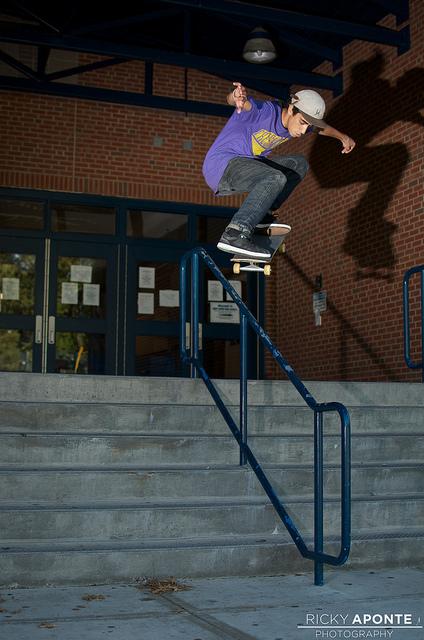What is the skateboard up against?
Answer briefly. Railing. What is behind this person?
Answer briefly. Building. Who is on the man's shirt?
Keep it brief. Warriors. What does the boy's shirt say?
Short answer required. Nothing. What is in the picture?
Answer briefly. Skateboarder. How many steps of stairs are there?
Answer briefly. 6. Is this a British motorbike?
Concise answer only. No. Is there writing on the rail?
Give a very brief answer. No. What is the boy riding on?
Short answer required. Skateboard. What color is the railing?
Answer briefly. Blue. Is the skateboarder trying to impress someone?
Concise answer only. Yes. Are the people watching the man skate?
Give a very brief answer. No. What sport is this?
Write a very short answer. Skateboarding. Is the guy practicing in a garage?
Short answer required. No. How many windows are on the building?
Short answer required. 4. Is he wearing a protective gear?
Be succinct. No. How many steps are there?
Write a very short answer. 6. Are these people standing on a tennis court?
Short answer required. No. How many boys are shown?
Write a very short answer. 1. Can these boys get sunburnt?
Quick response, please. No. What color shirt is the man wearing?
Short answer required. Blue. Has this person taken any safety precautions?
Answer briefly. No. What website is shown?
Give a very brief answer. Ricky aponte. What colors alternate on the railing?
Quick response, please. Blue. What is the shadow of in this photo?
Concise answer only. Skateboarder. Where was this picture taken?
Write a very short answer. Outside. Is he performing for an audience?
Quick response, please. No. What color are the steps?
Keep it brief. Gray. Is this guy wearing anything protective on his head?
Give a very brief answer. No. What color are the boy's shoes?
Concise answer only. Black. Is the boy wearing a helmet?
Be succinct. Yes. 